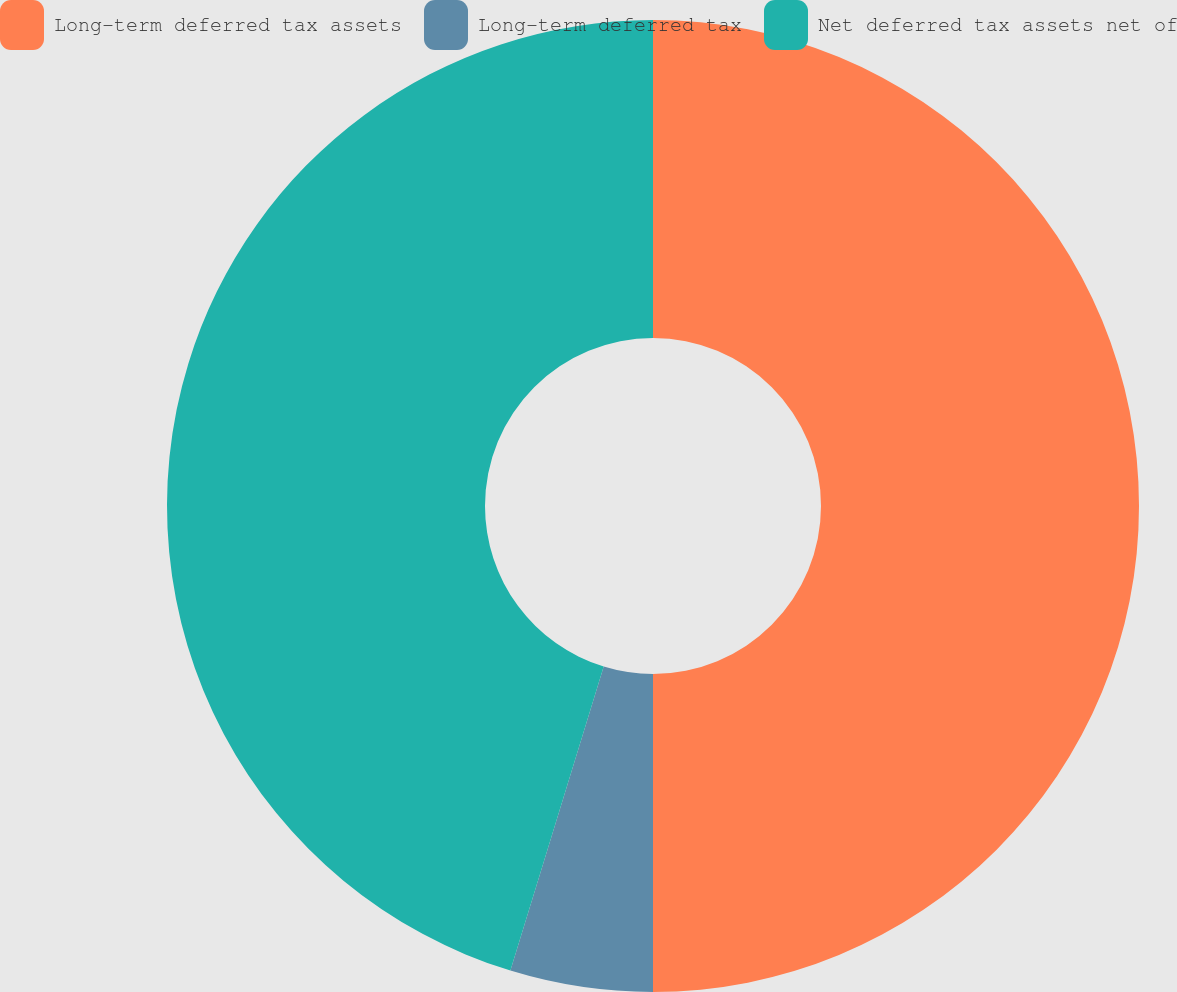Convert chart to OTSL. <chart><loc_0><loc_0><loc_500><loc_500><pie_chart><fcel>Long-term deferred tax assets<fcel>Long-term deferred tax<fcel>Net deferred tax assets net of<nl><fcel>50.0%<fcel>4.74%<fcel>45.26%<nl></chart> 